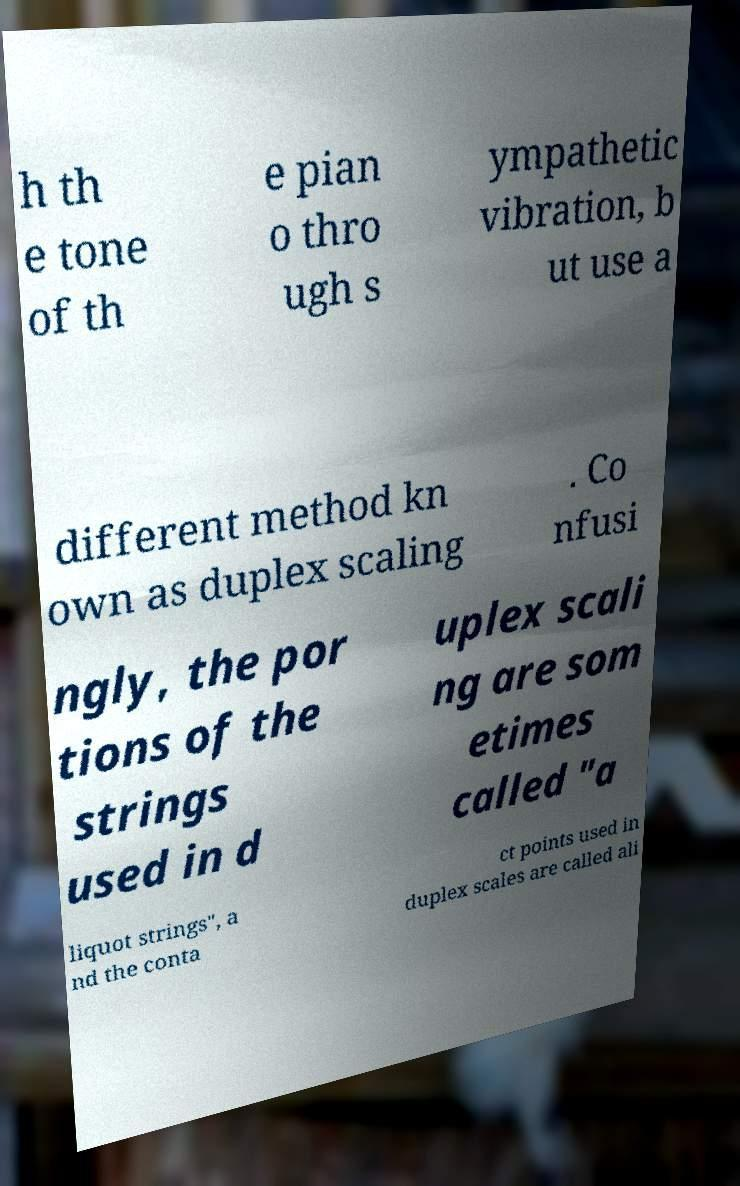I need the written content from this picture converted into text. Can you do that? h th e tone of th e pian o thro ugh s ympathetic vibration, b ut use a different method kn own as duplex scaling . Co nfusi ngly, the por tions of the strings used in d uplex scali ng are som etimes called "a liquot strings", a nd the conta ct points used in duplex scales are called ali 